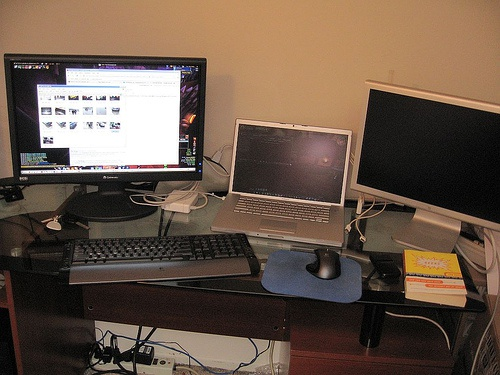Describe the objects in this image and their specific colors. I can see tv in gray, white, black, and darkgray tones, laptop in gray, brown, and black tones, keyboard in gray, black, and maroon tones, book in gray, tan, and orange tones, and keyboard in gray and maroon tones in this image. 